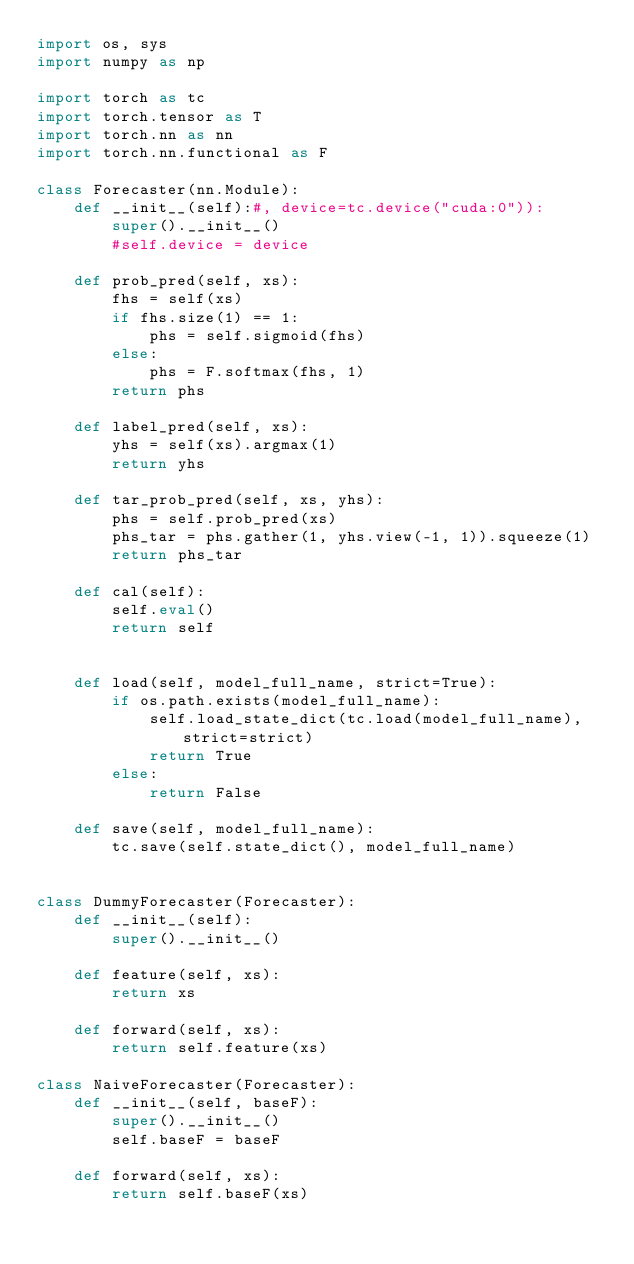Convert code to text. <code><loc_0><loc_0><loc_500><loc_500><_Python_>import os, sys
import numpy as np

import torch as tc
import torch.tensor as T
import torch.nn as nn
import torch.nn.functional as F

class Forecaster(nn.Module):
    def __init__(self):#, device=tc.device("cuda:0")):
        super().__init__()
        #self.device = device

    def prob_pred(self, xs):
        fhs = self(xs)
        if fhs.size(1) == 1:
            phs = self.sigmoid(fhs)
        else:
            phs = F.softmax(fhs, 1)
        return phs
    
    def label_pred(self, xs):
        yhs = self(xs).argmax(1)
        return yhs
    
    def tar_prob_pred(self, xs, yhs):
        phs = self.prob_pred(xs)
        phs_tar = phs.gather(1, yhs.view(-1, 1)).squeeze(1)
        return phs_tar
    
    def cal(self):
        self.eval()
        return self

    
    def load(self, model_full_name, strict=True):
        if os.path.exists(model_full_name):
            self.load_state_dict(tc.load(model_full_name), strict=strict)
            return True
        else:
            return False
        
    def save(self, model_full_name):
        tc.save(self.state_dict(), model_full_name)
        
        
class DummyForecaster(Forecaster):
    def __init__(self):
        super().__init__()
        
    def feature(self, xs):
        return xs
    
    def forward(self, xs):
        return self.feature(xs)
    
class NaiveForecaster(Forecaster):
    def __init__(self, baseF):
        super().__init__()
        self.baseF = baseF
    
    def forward(self, xs):
        return self.baseF(xs)
</code> 